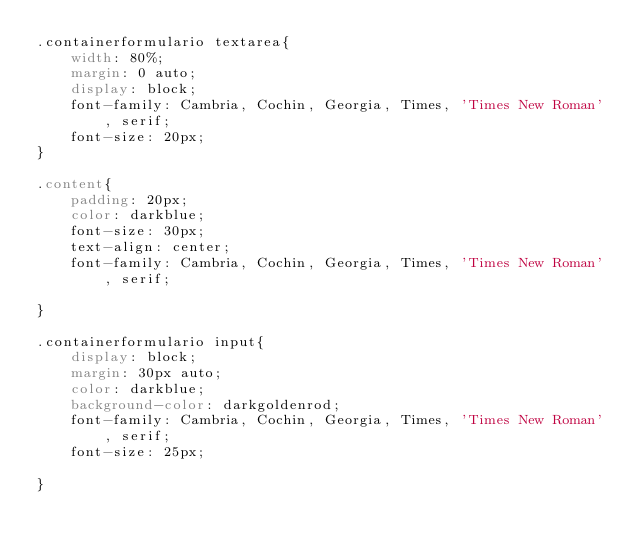<code> <loc_0><loc_0><loc_500><loc_500><_CSS_>.containerformulario textarea{
    width: 80%;
    margin: 0 auto;
    display: block;
    font-family: Cambria, Cochin, Georgia, Times, 'Times New Roman', serif;
    font-size: 20px;
}

.content{
    padding: 20px;
    color: darkblue;
    font-size: 30px;
    text-align: center;
    font-family: Cambria, Cochin, Georgia, Times, 'Times New Roman', serif;

}

.containerformulario input{
    display: block;
    margin: 30px auto;
    color: darkblue;
    background-color: darkgoldenrod;
    font-family: Cambria, Cochin, Georgia, Times, 'Times New Roman', serif;
    font-size: 25px;

}

</code> 